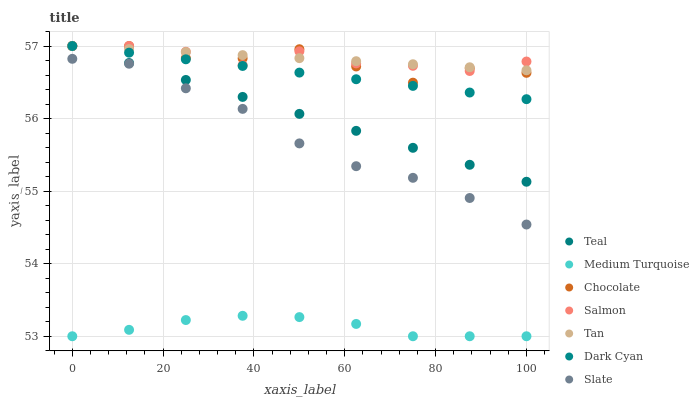Does Medium Turquoise have the minimum area under the curve?
Answer yes or no. Yes. Does Tan have the maximum area under the curve?
Answer yes or no. Yes. Does Slate have the minimum area under the curve?
Answer yes or no. No. Does Slate have the maximum area under the curve?
Answer yes or no. No. Is Tan the smoothest?
Answer yes or no. Yes. Is Chocolate the roughest?
Answer yes or no. Yes. Is Slate the smoothest?
Answer yes or no. No. Is Slate the roughest?
Answer yes or no. No. Does Medium Turquoise have the lowest value?
Answer yes or no. Yes. Does Slate have the lowest value?
Answer yes or no. No. Does Tan have the highest value?
Answer yes or no. Yes. Does Slate have the highest value?
Answer yes or no. No. Is Slate less than Tan?
Answer yes or no. Yes. Is Salmon greater than Medium Turquoise?
Answer yes or no. Yes. Does Teal intersect Tan?
Answer yes or no. Yes. Is Teal less than Tan?
Answer yes or no. No. Is Teal greater than Tan?
Answer yes or no. No. Does Slate intersect Tan?
Answer yes or no. No. 